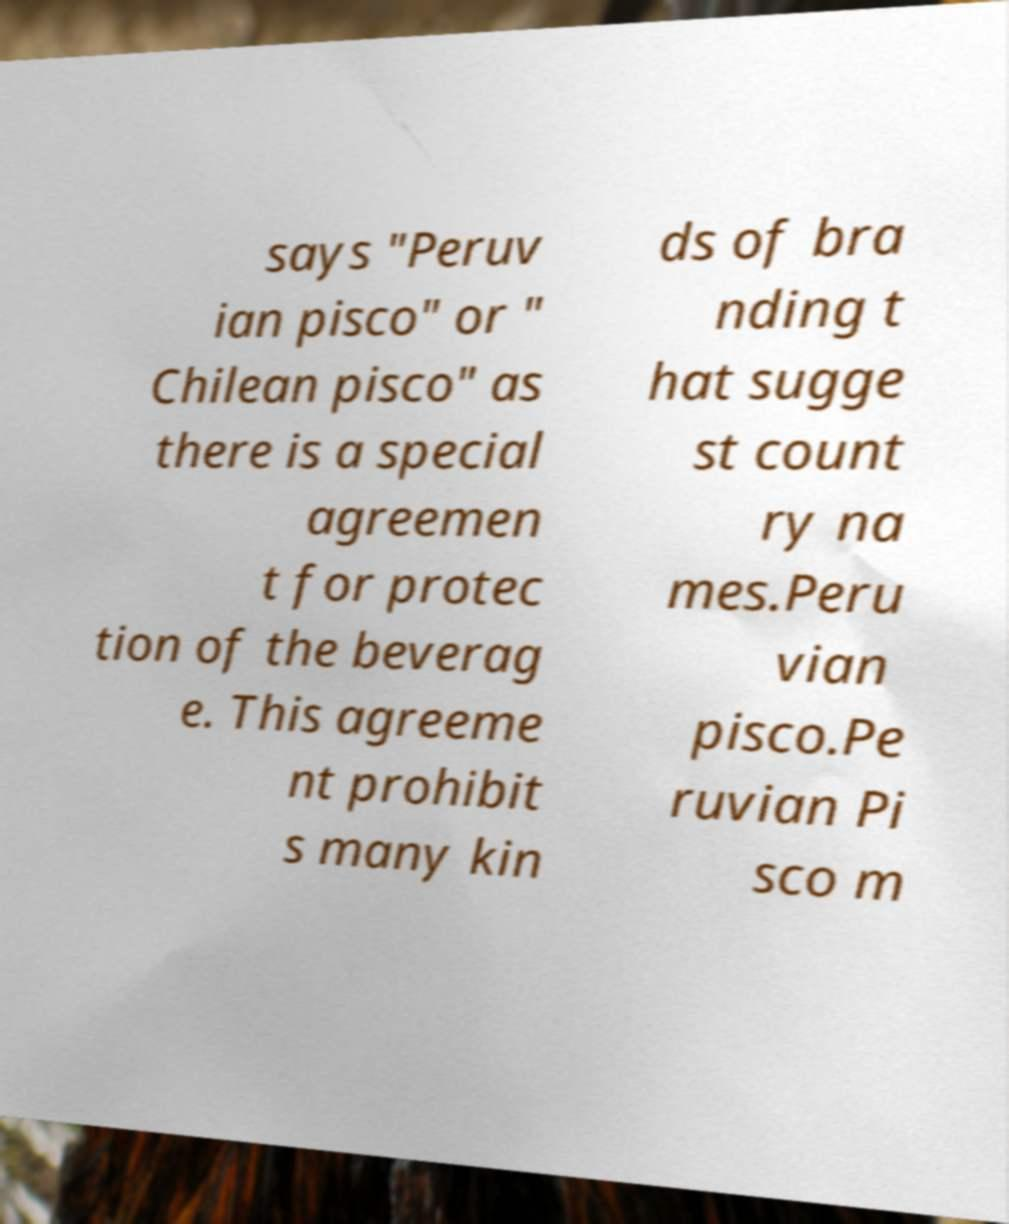Could you extract and type out the text from this image? says "Peruv ian pisco" or " Chilean pisco" as there is a special agreemen t for protec tion of the beverag e. This agreeme nt prohibit s many kin ds of bra nding t hat sugge st count ry na mes.Peru vian pisco.Pe ruvian Pi sco m 